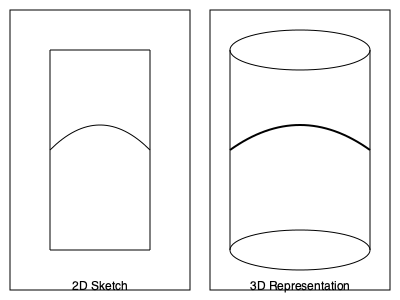As a costume designer presents you with a 2D sketch for a new character outfit, how would you interpret the curved line across the midsection in the 3D representation of the costume? 1. Observe the 2D sketch on the left side of the image. It shows a simple rectangular shape representing a basic costume outline.

2. Notice the curved line across the midsection of the 2D sketch. This line is drawn as a simple curve from left to right.

3. Now, look at the 3D representation on the right side of the image. The overall shape has been transformed into a cylindrical form to represent a three-dimensional costume.

4. The curved line from the 2D sketch has been translated into a more complex curve in the 3D representation.

5. In the 3D version, the curve appears to wrap around the cylindrical form, creating a sense of depth and volume.

6. The curve in the 3D representation is more pronounced in the center and tapers off towards the sides, suggesting a gathered or cinched effect at the waist.

7. This transformation from 2D to 3D illustrates how a simple curved line can represent a belt, sash, or gathered fabric detail that contours to the body's shape in three dimensions.

8. The 3D interpretation adds depth and realism to the costume design, helping actors and costume makers better understand how the final outfit will look and fit on a real person.
Answer: A gathered or cinched waist detail wrapping around the body 